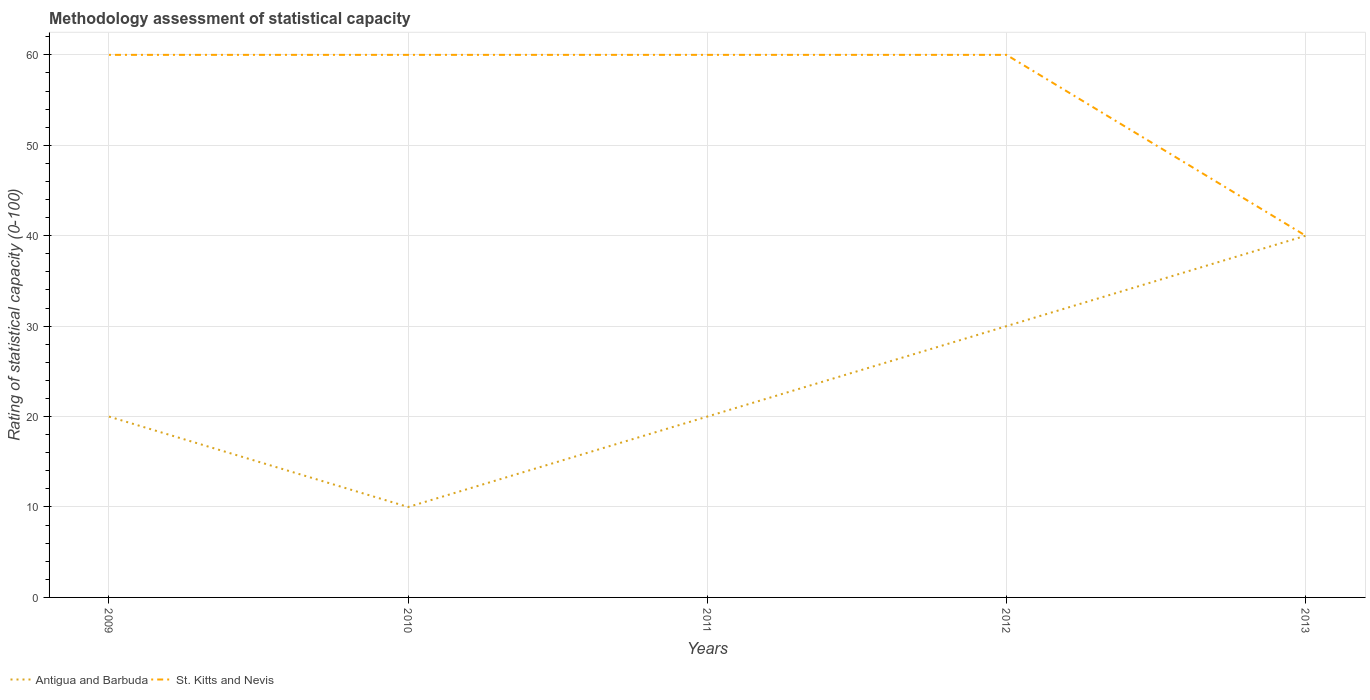How many different coloured lines are there?
Ensure brevity in your answer.  2. Does the line corresponding to St. Kitts and Nevis intersect with the line corresponding to Antigua and Barbuda?
Provide a succinct answer. Yes. In which year was the rating of statistical capacity in Antigua and Barbuda maximum?
Make the answer very short. 2010. What is the total rating of statistical capacity in St. Kitts and Nevis in the graph?
Your response must be concise. 0. What is the difference between the highest and the lowest rating of statistical capacity in St. Kitts and Nevis?
Offer a very short reply. 4. Is the rating of statistical capacity in Antigua and Barbuda strictly greater than the rating of statistical capacity in St. Kitts and Nevis over the years?
Your answer should be compact. No. How many lines are there?
Ensure brevity in your answer.  2. What is the difference between two consecutive major ticks on the Y-axis?
Ensure brevity in your answer.  10. Where does the legend appear in the graph?
Your answer should be compact. Bottom left. How many legend labels are there?
Your answer should be very brief. 2. What is the title of the graph?
Provide a succinct answer. Methodology assessment of statistical capacity. What is the label or title of the X-axis?
Offer a very short reply. Years. What is the label or title of the Y-axis?
Keep it short and to the point. Rating of statistical capacity (0-100). What is the Rating of statistical capacity (0-100) in St. Kitts and Nevis in 2009?
Your answer should be compact. 60. What is the Rating of statistical capacity (0-100) in Antigua and Barbuda in 2010?
Provide a short and direct response. 10. What is the Rating of statistical capacity (0-100) in Antigua and Barbuda in 2011?
Give a very brief answer. 20. What is the Rating of statistical capacity (0-100) in Antigua and Barbuda in 2012?
Make the answer very short. 30. What is the Rating of statistical capacity (0-100) of St. Kitts and Nevis in 2012?
Provide a succinct answer. 60. Across all years, what is the maximum Rating of statistical capacity (0-100) in Antigua and Barbuda?
Your response must be concise. 40. Across all years, what is the minimum Rating of statistical capacity (0-100) of Antigua and Barbuda?
Provide a short and direct response. 10. What is the total Rating of statistical capacity (0-100) in Antigua and Barbuda in the graph?
Give a very brief answer. 120. What is the total Rating of statistical capacity (0-100) in St. Kitts and Nevis in the graph?
Offer a terse response. 280. What is the difference between the Rating of statistical capacity (0-100) in St. Kitts and Nevis in 2009 and that in 2011?
Your answer should be very brief. 0. What is the difference between the Rating of statistical capacity (0-100) of Antigua and Barbuda in 2009 and that in 2012?
Your answer should be very brief. -10. What is the difference between the Rating of statistical capacity (0-100) of Antigua and Barbuda in 2010 and that in 2011?
Make the answer very short. -10. What is the difference between the Rating of statistical capacity (0-100) in St. Kitts and Nevis in 2010 and that in 2011?
Ensure brevity in your answer.  0. What is the difference between the Rating of statistical capacity (0-100) in Antigua and Barbuda in 2010 and that in 2012?
Your answer should be very brief. -20. What is the difference between the Rating of statistical capacity (0-100) of Antigua and Barbuda in 2011 and that in 2012?
Your response must be concise. -10. What is the difference between the Rating of statistical capacity (0-100) of Antigua and Barbuda in 2012 and that in 2013?
Your answer should be very brief. -10. What is the difference between the Rating of statistical capacity (0-100) of Antigua and Barbuda in 2009 and the Rating of statistical capacity (0-100) of St. Kitts and Nevis in 2013?
Provide a succinct answer. -20. What is the average Rating of statistical capacity (0-100) in Antigua and Barbuda per year?
Give a very brief answer. 24. What is the average Rating of statistical capacity (0-100) of St. Kitts and Nevis per year?
Keep it short and to the point. 56. In the year 2009, what is the difference between the Rating of statistical capacity (0-100) in Antigua and Barbuda and Rating of statistical capacity (0-100) in St. Kitts and Nevis?
Provide a succinct answer. -40. In the year 2010, what is the difference between the Rating of statistical capacity (0-100) in Antigua and Barbuda and Rating of statistical capacity (0-100) in St. Kitts and Nevis?
Provide a succinct answer. -50. In the year 2011, what is the difference between the Rating of statistical capacity (0-100) of Antigua and Barbuda and Rating of statistical capacity (0-100) of St. Kitts and Nevis?
Provide a succinct answer. -40. In the year 2012, what is the difference between the Rating of statistical capacity (0-100) in Antigua and Barbuda and Rating of statistical capacity (0-100) in St. Kitts and Nevis?
Your answer should be compact. -30. In the year 2013, what is the difference between the Rating of statistical capacity (0-100) in Antigua and Barbuda and Rating of statistical capacity (0-100) in St. Kitts and Nevis?
Provide a short and direct response. 0. What is the ratio of the Rating of statistical capacity (0-100) in Antigua and Barbuda in 2009 to that in 2011?
Make the answer very short. 1. What is the ratio of the Rating of statistical capacity (0-100) of Antigua and Barbuda in 2010 to that in 2012?
Ensure brevity in your answer.  0.33. What is the ratio of the Rating of statistical capacity (0-100) in St. Kitts and Nevis in 2010 to that in 2013?
Provide a succinct answer. 1.5. What is the ratio of the Rating of statistical capacity (0-100) of Antigua and Barbuda in 2011 to that in 2013?
Give a very brief answer. 0.5. What is the ratio of the Rating of statistical capacity (0-100) of St. Kitts and Nevis in 2011 to that in 2013?
Provide a succinct answer. 1.5. What is the ratio of the Rating of statistical capacity (0-100) in St. Kitts and Nevis in 2012 to that in 2013?
Offer a terse response. 1.5. What is the difference between the highest and the second highest Rating of statistical capacity (0-100) in St. Kitts and Nevis?
Keep it short and to the point. 0. 